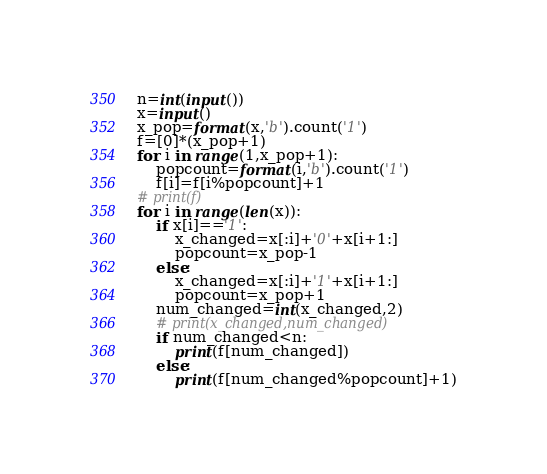Convert code to text. <code><loc_0><loc_0><loc_500><loc_500><_Python_>n=int(input())
x=input()
x_pop=format(x,'b').count('1')
f=[0]*(x_pop+1)
for i in range(1,x_pop+1):
    popcount=format(i,'b').count('1')
    f[i]=f[i%popcount]+1
# print(f)
for i in range(len(x)):
    if x[i]=='1':
        x_changed=x[:i]+'0'+x[i+1:]
        popcount=x_pop-1
    else:
        x_changed=x[:i]+'1'+x[i+1:]
        popcount=x_pop+1
    num_changed=int(x_changed,2)
    # print(x_changed,num_changed)
    if num_changed<n:
        print(f[num_changed])
    else:
        print(f[num_changed%popcount]+1)
</code> 